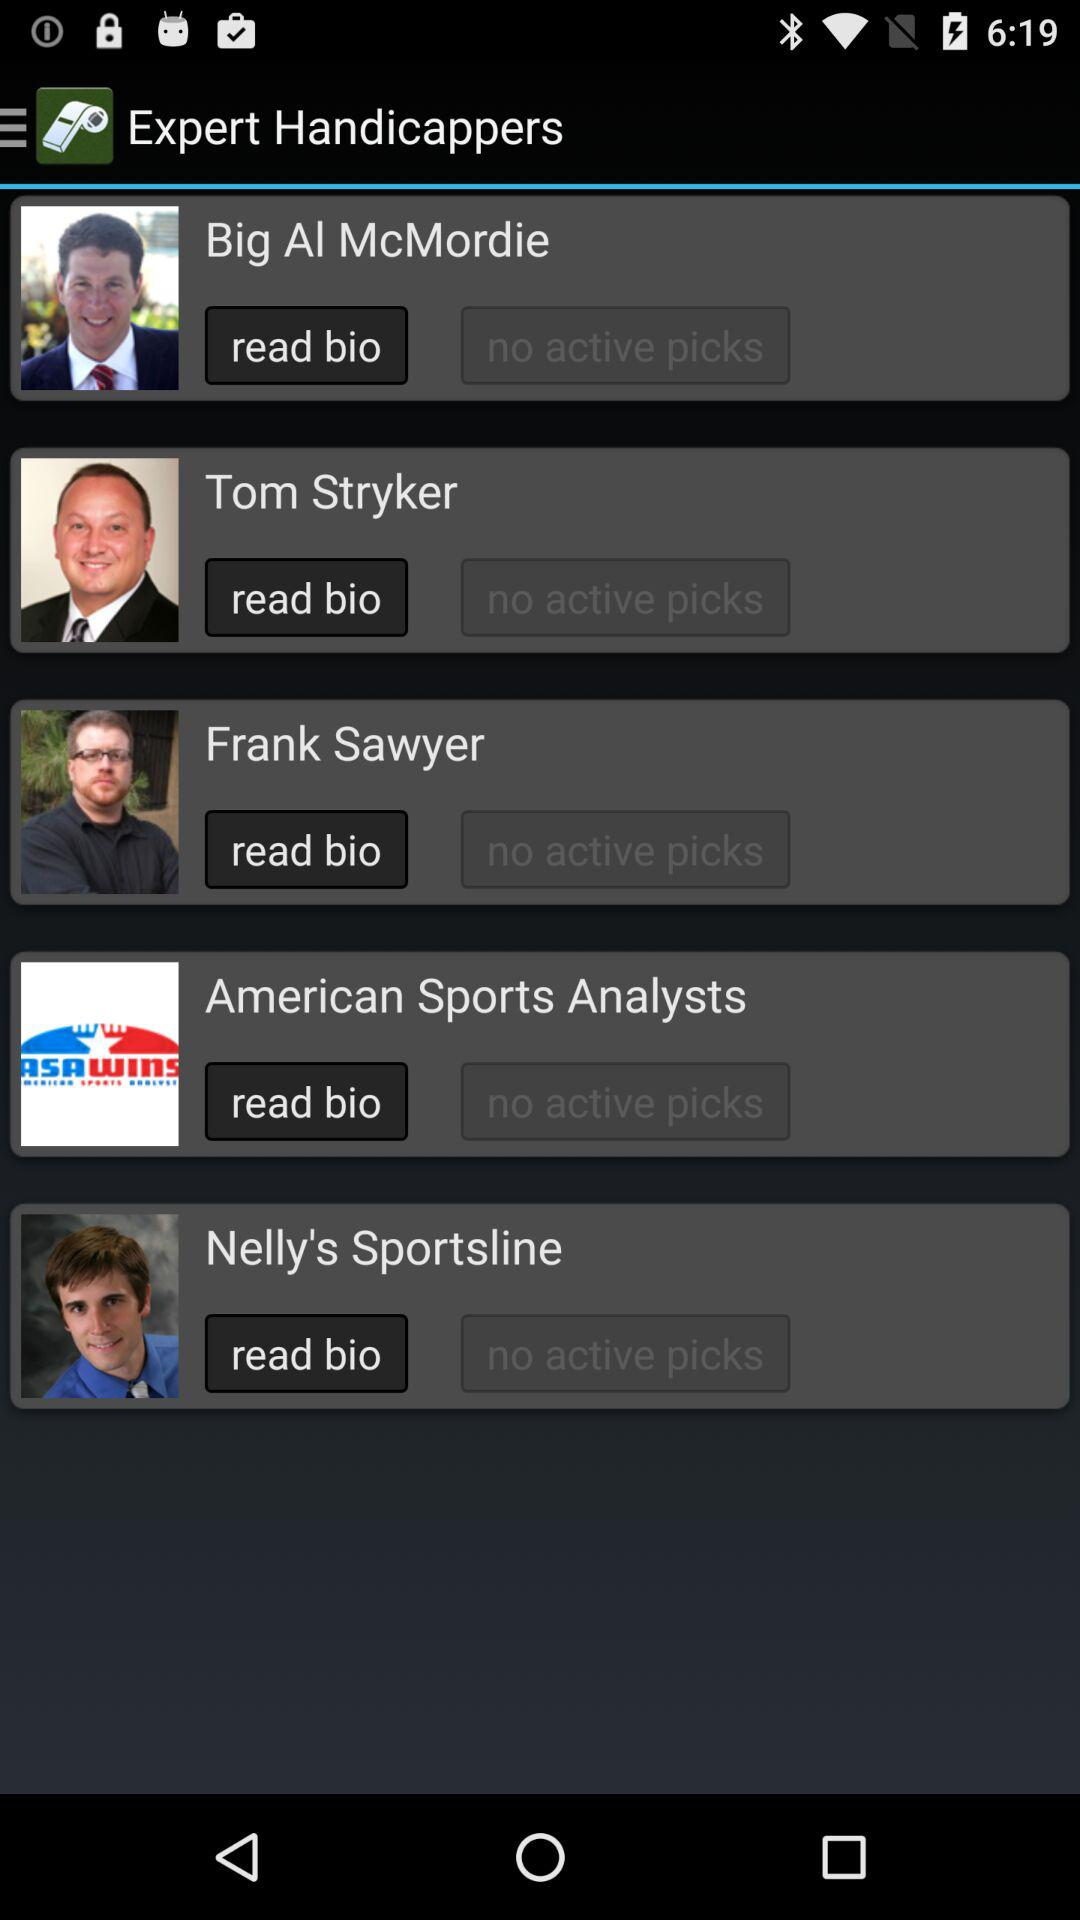How many handicappers have a picture of themselves?
Answer the question using a single word or phrase. 4 